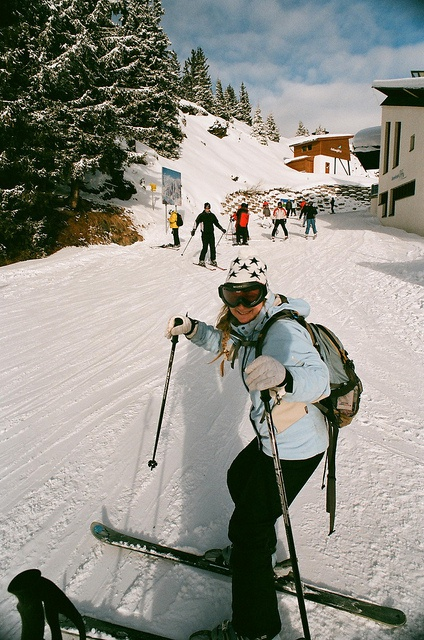Describe the objects in this image and their specific colors. I can see people in black, darkgray, lightgray, and gray tones, skis in black, gray, darkgray, and darkgreen tones, backpack in black, gray, darkgray, and olive tones, people in black, gray, lightgray, and darkgray tones, and people in black, red, maroon, and brown tones in this image. 